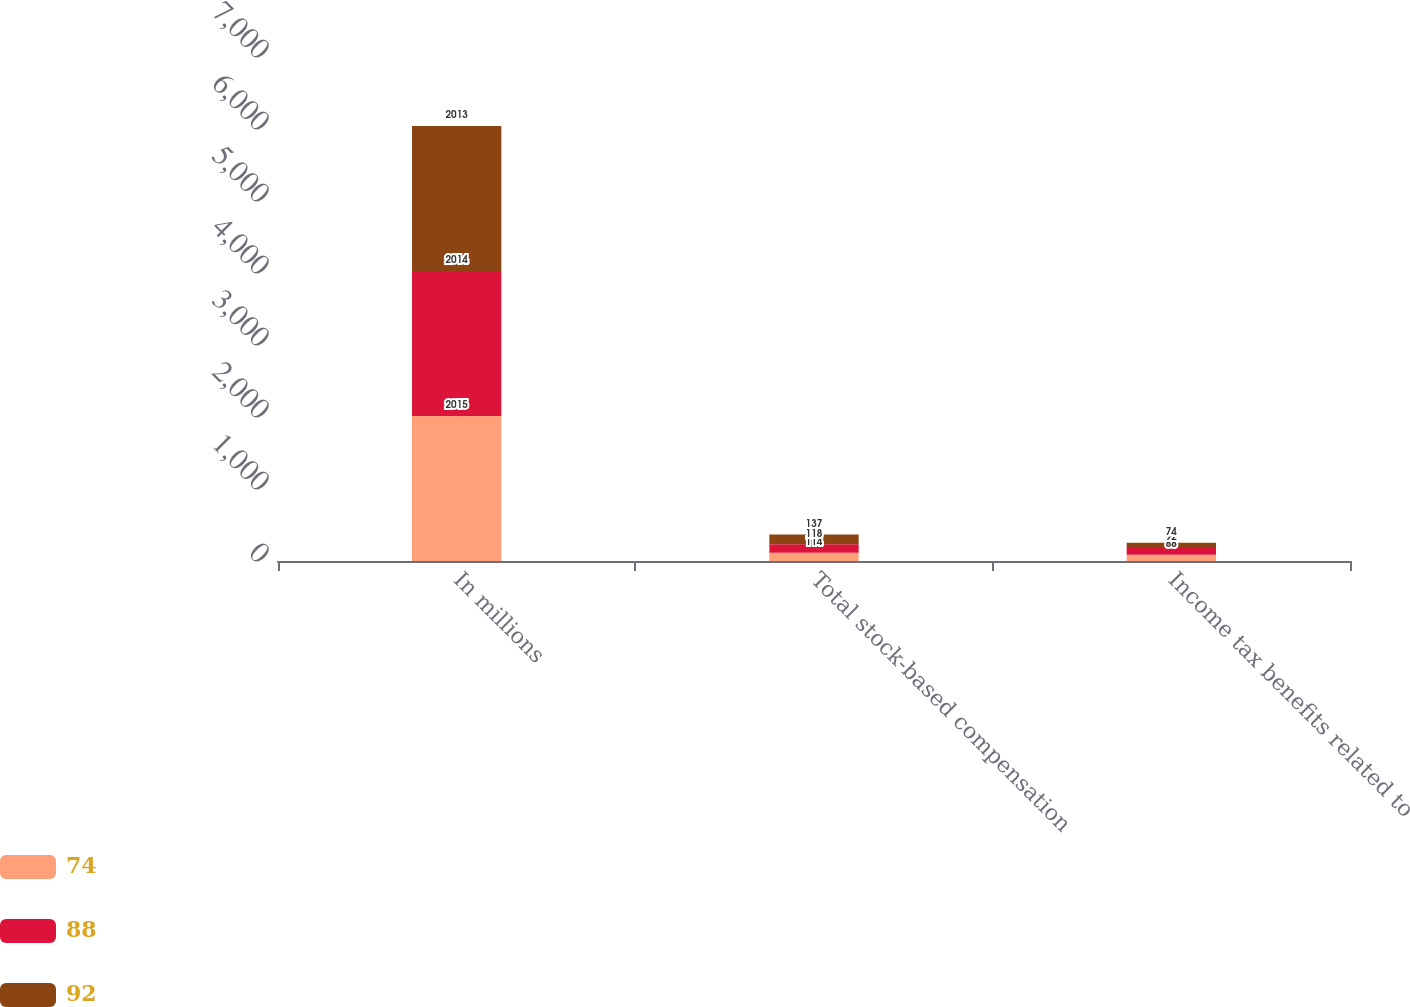Convert chart to OTSL. <chart><loc_0><loc_0><loc_500><loc_500><stacked_bar_chart><ecel><fcel>In millions<fcel>Total stock-based compensation<fcel>Income tax benefits related to<nl><fcel>74<fcel>2015<fcel>114<fcel>88<nl><fcel>88<fcel>2014<fcel>118<fcel>92<nl><fcel>92<fcel>2013<fcel>137<fcel>74<nl></chart> 